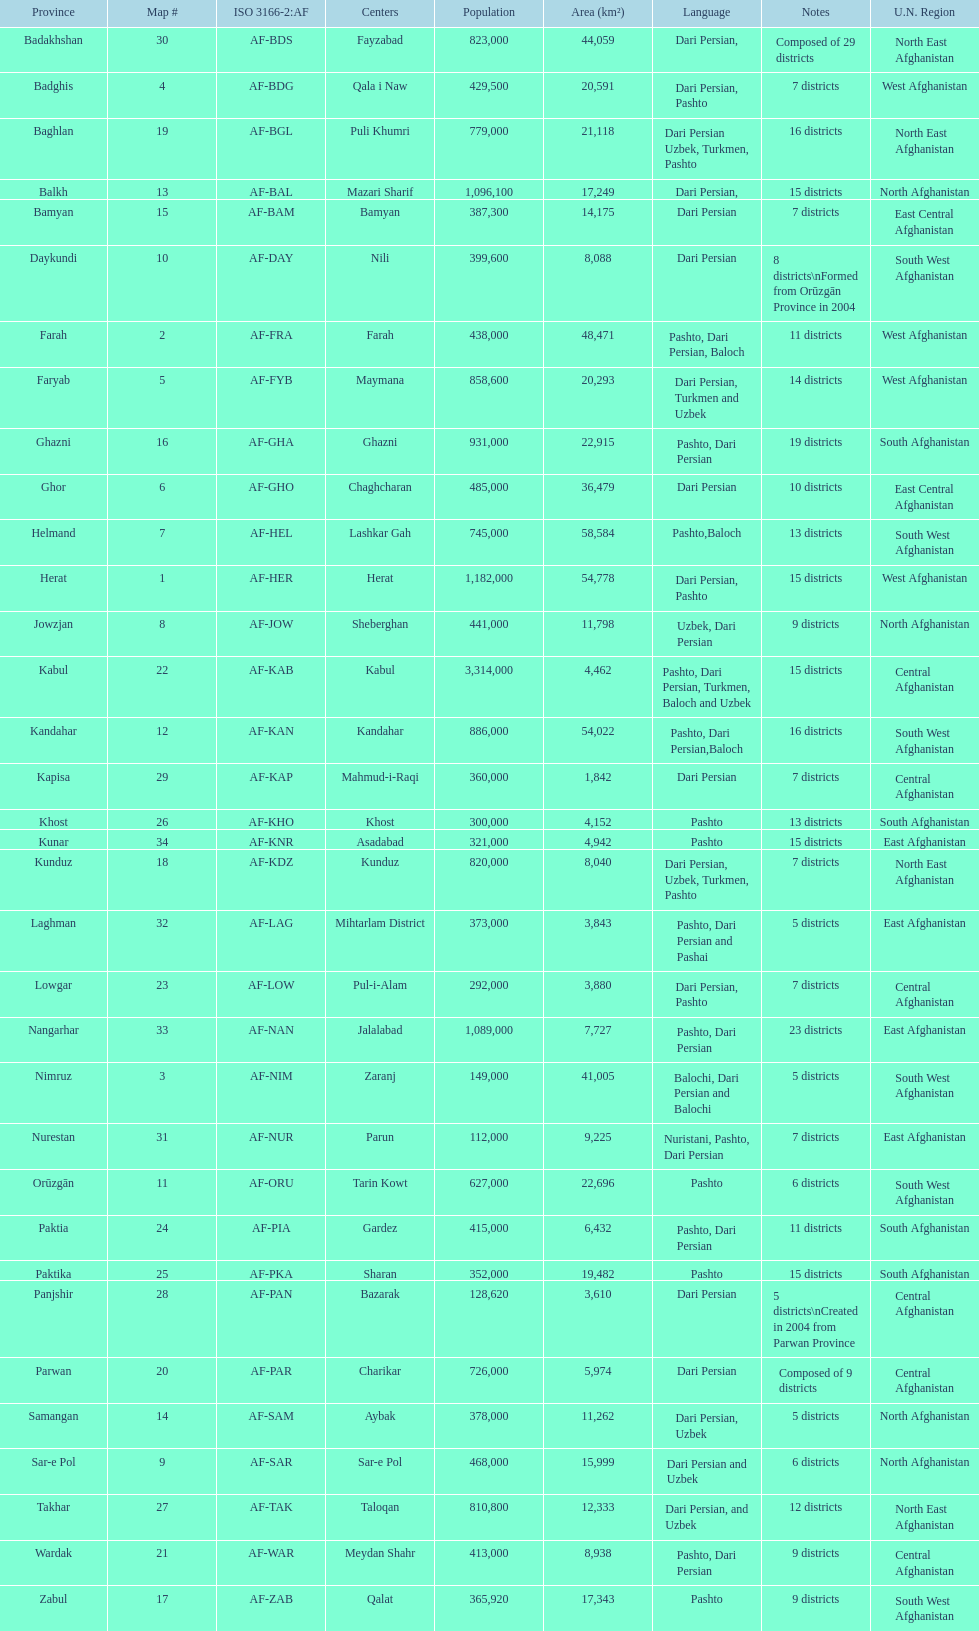Does ghor or farah possess more districts? Farah. 